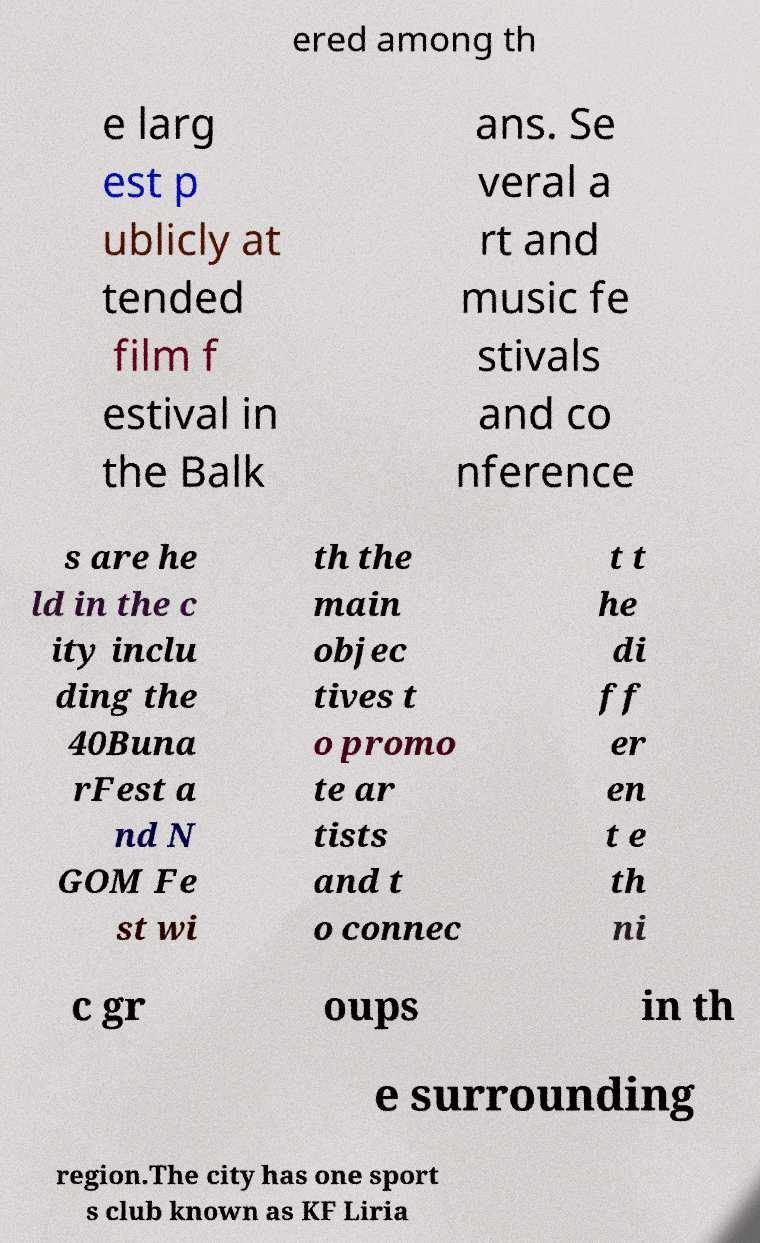There's text embedded in this image that I need extracted. Can you transcribe it verbatim? ered among th e larg est p ublicly at tended film f estival in the Balk ans. Se veral a rt and music fe stivals and co nference s are he ld in the c ity inclu ding the 40Buna rFest a nd N GOM Fe st wi th the main objec tives t o promo te ar tists and t o connec t t he di ff er en t e th ni c gr oups in th e surrounding region.The city has one sport s club known as KF Liria 